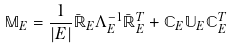<formula> <loc_0><loc_0><loc_500><loc_500>\mathbb { M } _ { E } = \frac { 1 } { | E | } \bar { \mathbb { R } } _ { E } \Lambda _ { E } ^ { - 1 } \bar { \mathbb { R } } _ { E } ^ { T } + \mathbb { C } _ { E } \mathbb { U } _ { E } \mathbb { C } _ { E } ^ { T }</formula> 